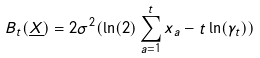<formula> <loc_0><loc_0><loc_500><loc_500>B _ { t } ( \underline { X } ) = 2 \sigma ^ { 2 } ( \ln ( 2 ) \sum _ { a = 1 } ^ { t } x _ { a } - t \ln ( \gamma _ { t } ) )</formula> 